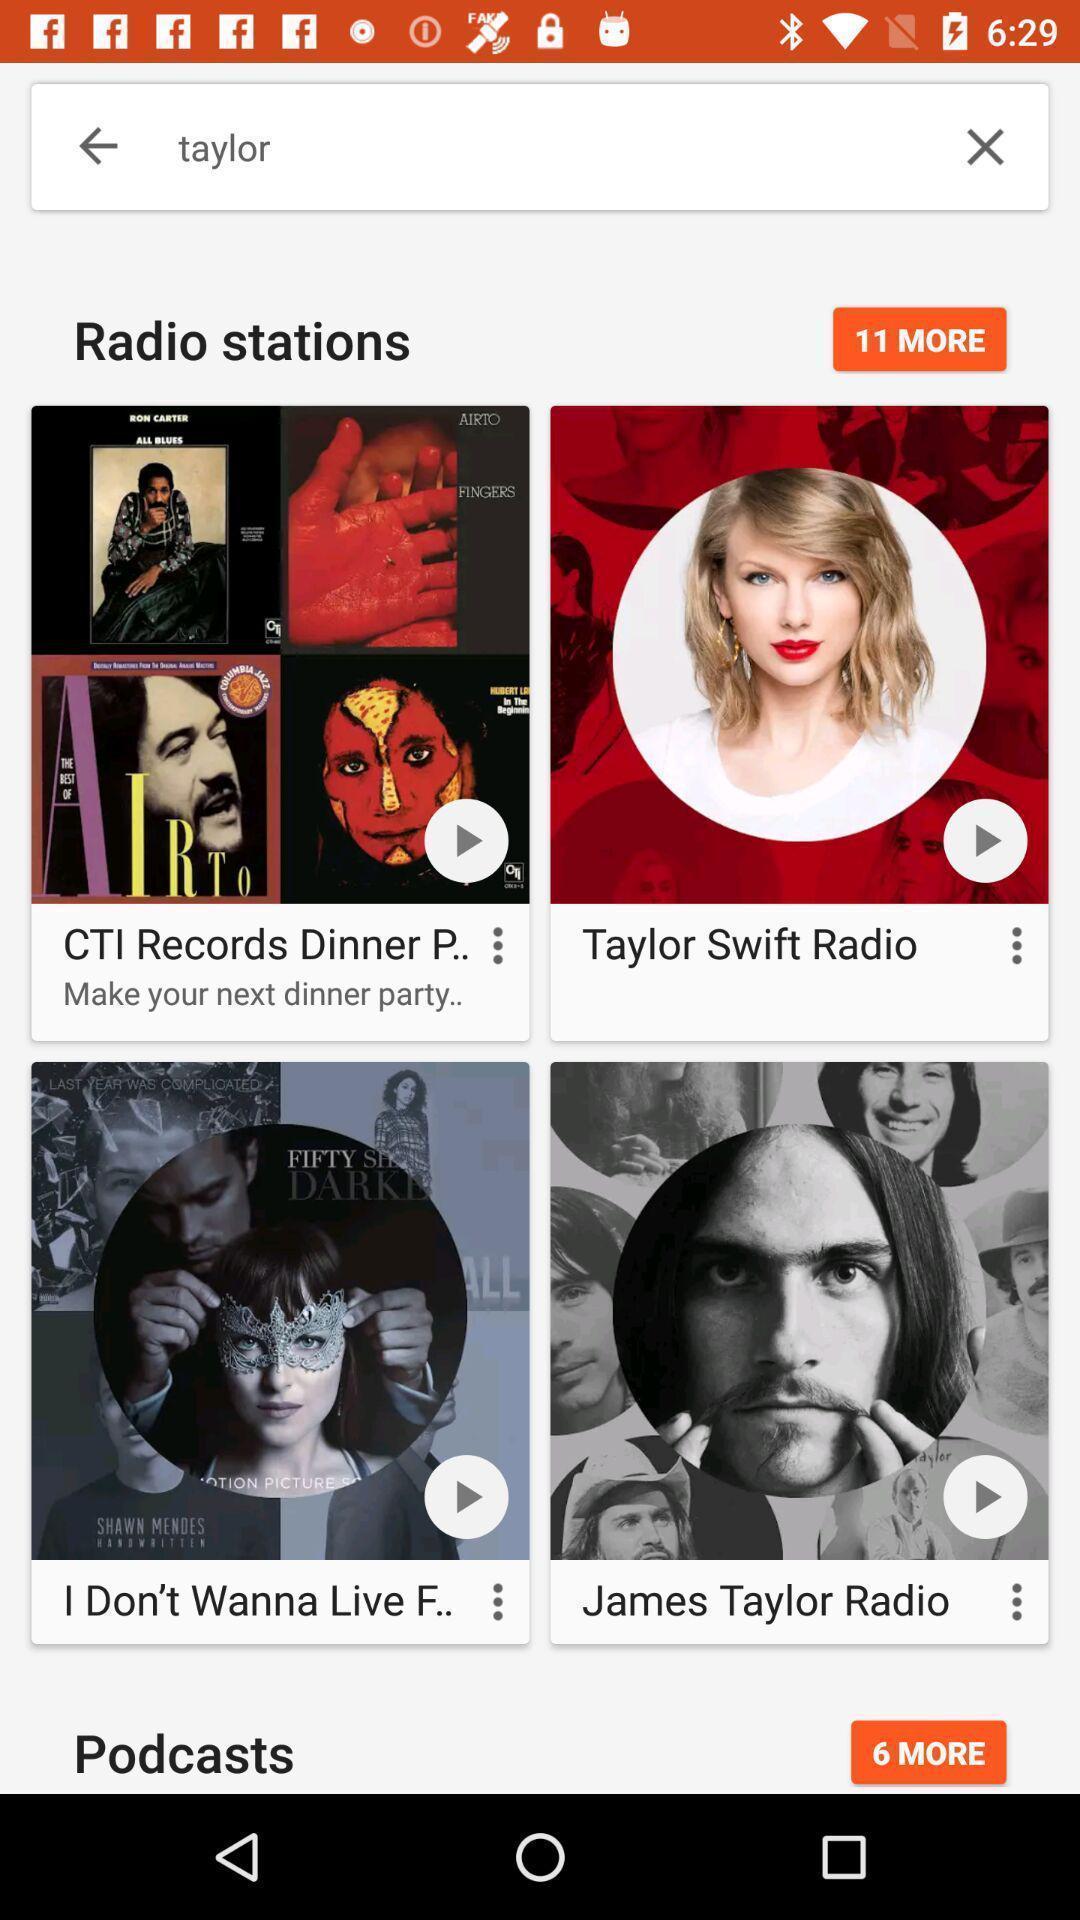What details can you identify in this image? Various search results page displayed on a music app. 